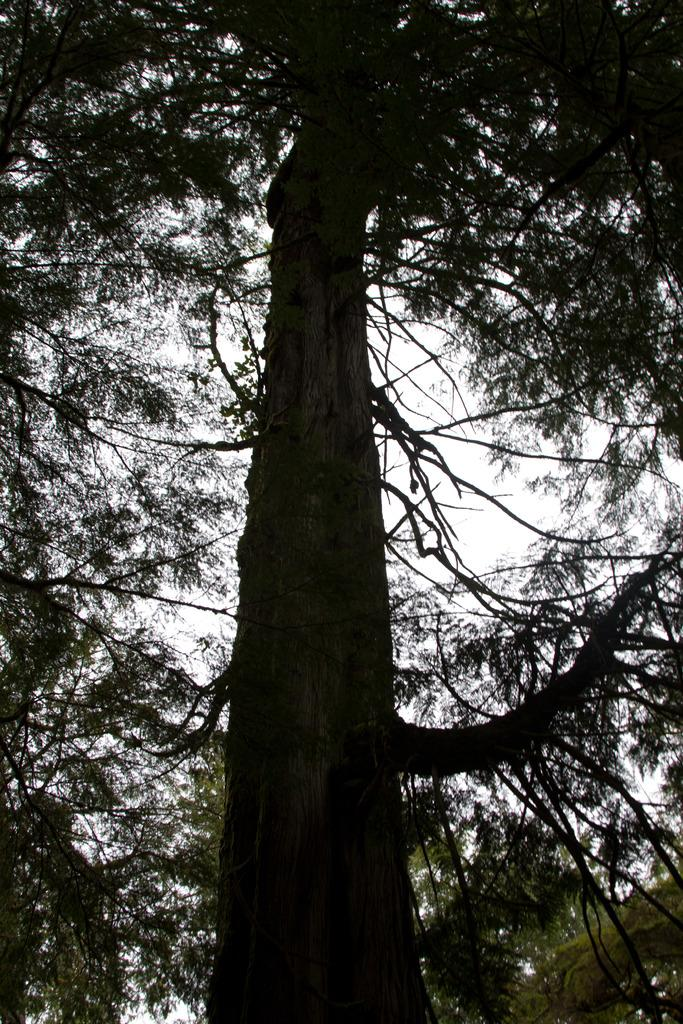What type of plant is the main subject of the image? There is a tall tree with many branches in the image. What can be seen in the background of the image? The sky is visible in the background of the image. What type of soup is being served in the image? There is no soup present in the image; it features a tall tree with many branches and a visible sky in the background. 